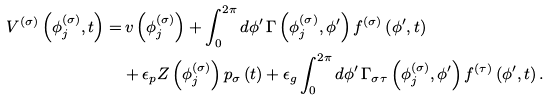<formula> <loc_0><loc_0><loc_500><loc_500>V ^ { ( \sigma ) } \left ( \phi _ { j } ^ { ( \sigma ) } , t \right ) = & \, v \left ( \phi _ { j } ^ { ( \sigma ) } \right ) + \int _ { 0 } ^ { 2 \pi } d \phi ^ { \prime } \, \Gamma \left ( \phi _ { j } ^ { ( \sigma ) } , \phi ^ { \prime } \right ) f ^ { ( \sigma ) } \left ( \phi ^ { \prime } , t \right ) \\ & + \epsilon _ { p } Z \left ( \phi _ { j } ^ { ( \sigma ) } \right ) p _ { \sigma } \left ( t \right ) + \epsilon _ { g } \int _ { 0 } ^ { 2 \pi } d \phi ^ { \prime } \, \Gamma _ { \sigma \tau } \left ( \phi _ { j } ^ { ( \sigma ) } , \phi ^ { \prime } \right ) f ^ { ( \tau ) } \left ( \phi ^ { \prime } , t \right ) .</formula> 